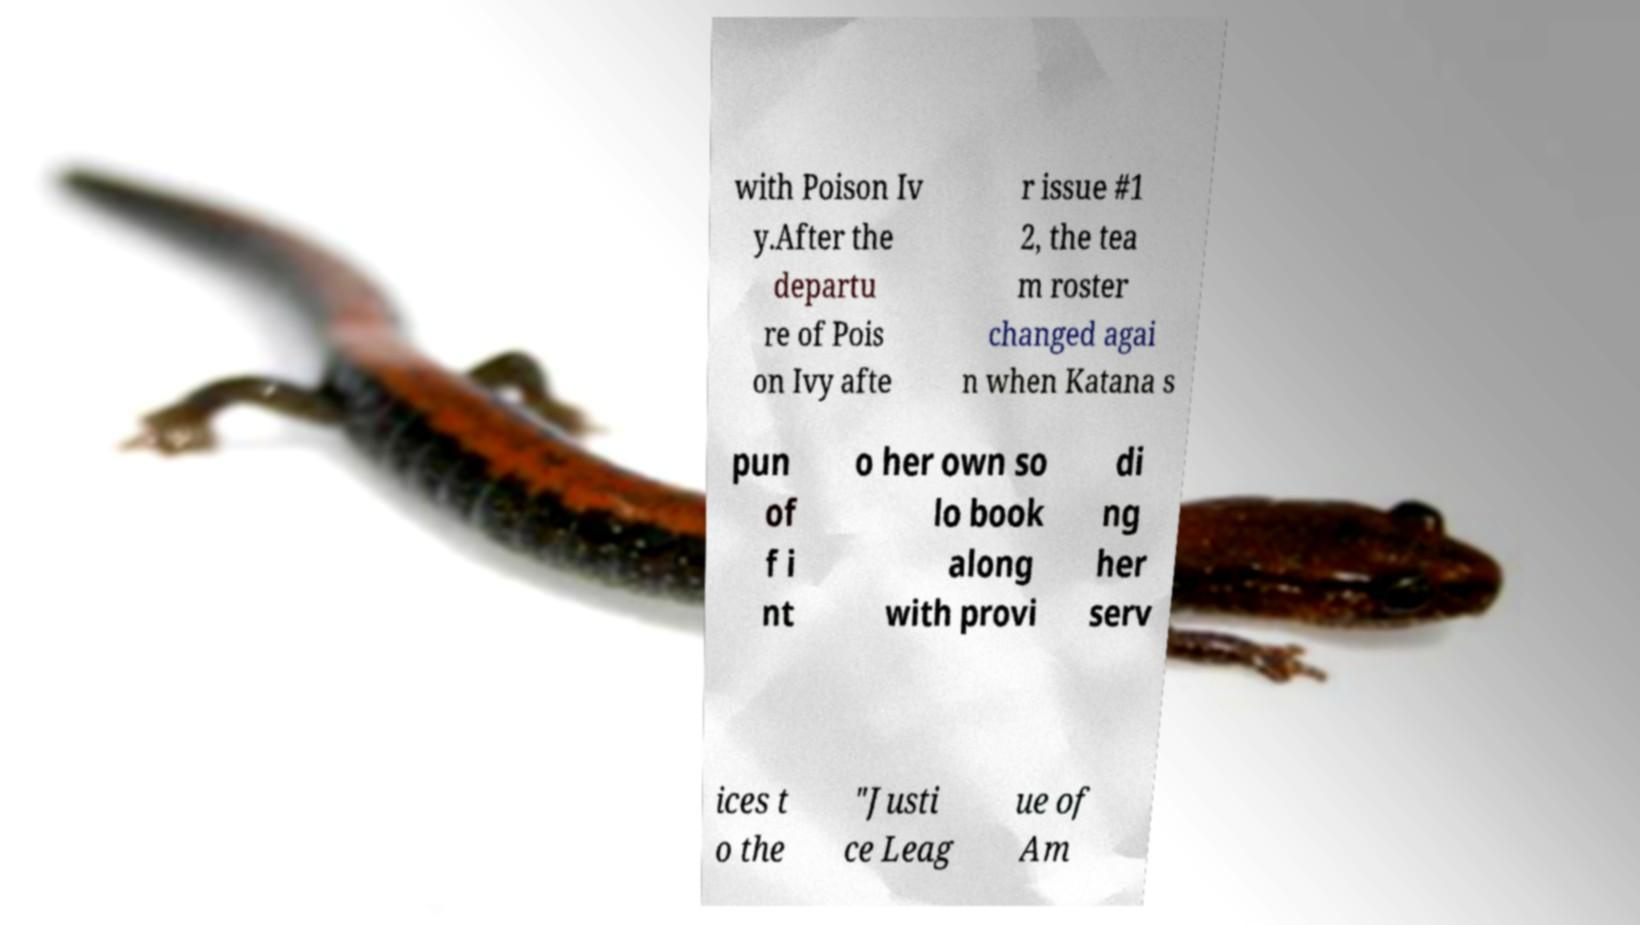Could you extract and type out the text from this image? with Poison Iv y.After the departu re of Pois on Ivy afte r issue #1 2, the tea m roster changed agai n when Katana s pun of f i nt o her own so lo book along with provi di ng her serv ices t o the "Justi ce Leag ue of Am 